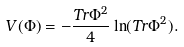<formula> <loc_0><loc_0><loc_500><loc_500>V ( \Phi ) = - \frac { T r \Phi ^ { 2 } } { 4 } \ln ( T r \Phi ^ { 2 } ) .</formula> 